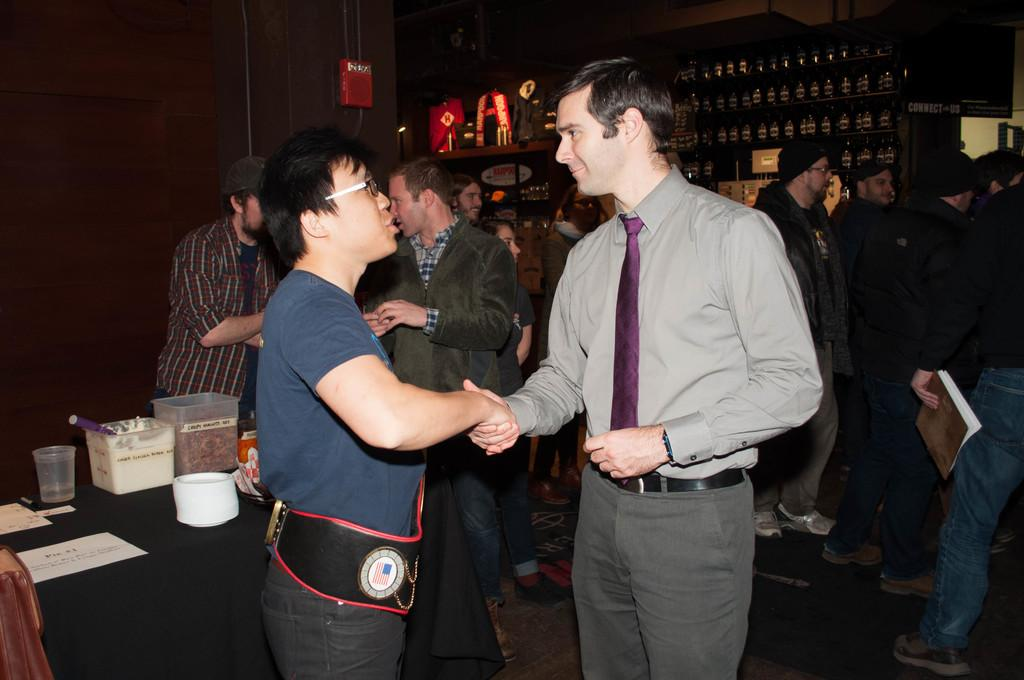What are the two men in the foreground of the image doing? The two men in the foreground of the image are shaking hands. What can be seen in the background of the image? In the background of the image, there are people, bottles, posters, and other objects. Can you describe the objects in the background of the image? The objects in the background of the image include bottles and posters, as well as other unspecified objects. What type of salt can be seen on the beds in the image? There are no beds or salt present in the image. 